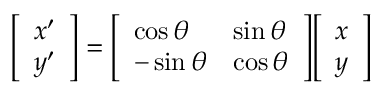Convert formula to latex. <formula><loc_0><loc_0><loc_500><loc_500>{ \left [ \begin{array} { l } { x ^ { \prime } } \\ { y ^ { \prime } } \end{array} \right ] } = { \left [ \begin{array} { l l } { \cos \theta } & { \sin \theta } \\ { - \sin \theta } & { \cos \theta } \end{array} \right ] } { \left [ \begin{array} { l } { x } \\ { y } \end{array} \right ] }</formula> 